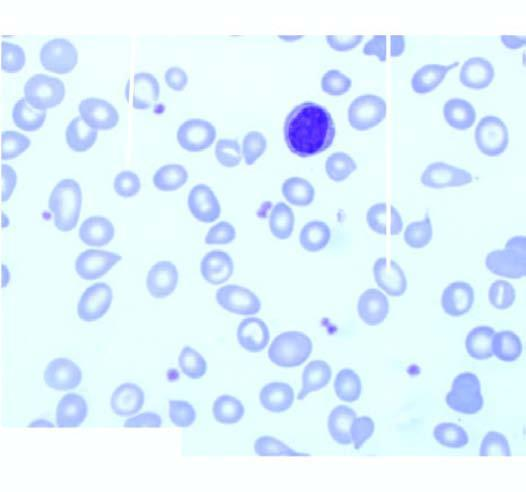does examination of bone marrow aspirate show micronormoblastic erythropoiesis?
Answer the question using a single word or phrase. Yes 